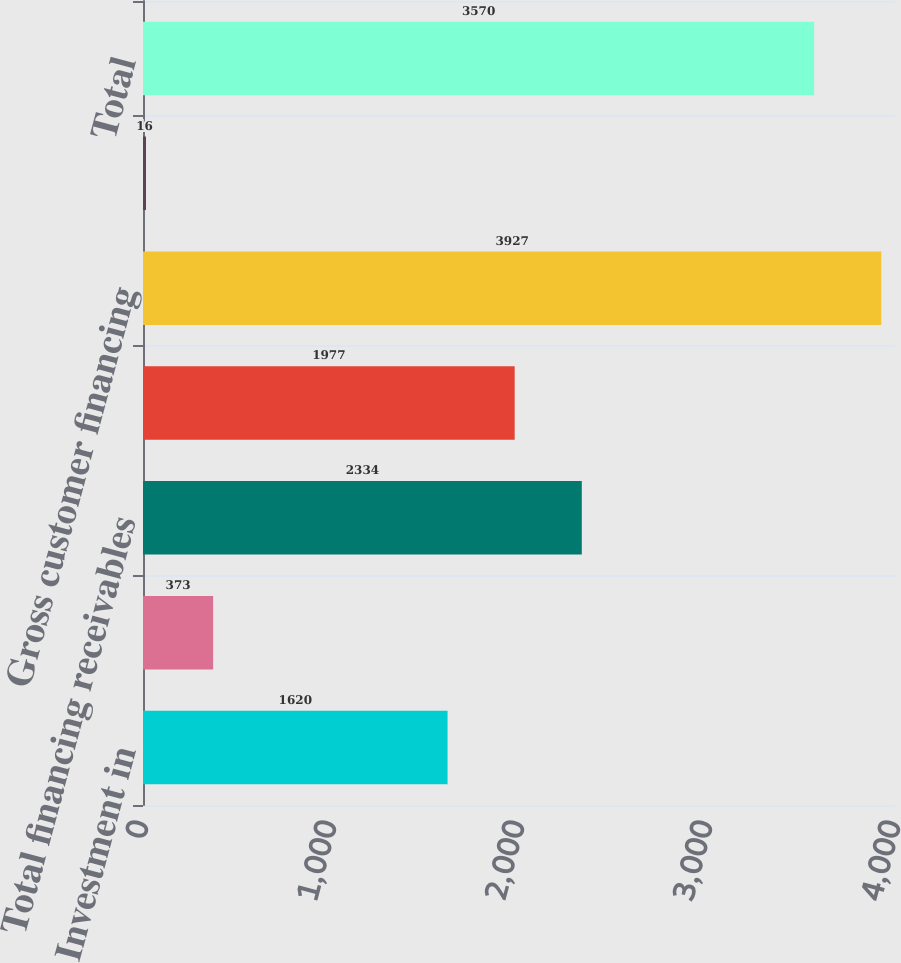Convert chart. <chart><loc_0><loc_0><loc_500><loc_500><bar_chart><fcel>Investment in<fcel>Notes<fcel>Total financing receivables<fcel>Operating lease equipment at<fcel>Gross customer financing<fcel>Less allowance for losses on<fcel>Total<nl><fcel>1620<fcel>373<fcel>2334<fcel>1977<fcel>3927<fcel>16<fcel>3570<nl></chart> 